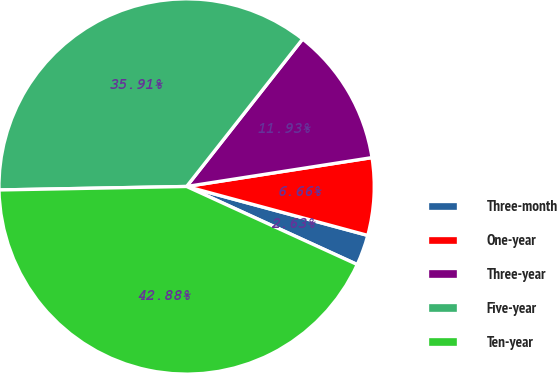<chart> <loc_0><loc_0><loc_500><loc_500><pie_chart><fcel>Three-month<fcel>One-year<fcel>Three-year<fcel>Five-year<fcel>Ten-year<nl><fcel>2.63%<fcel>6.66%<fcel>11.93%<fcel>35.91%<fcel>42.88%<nl></chart> 